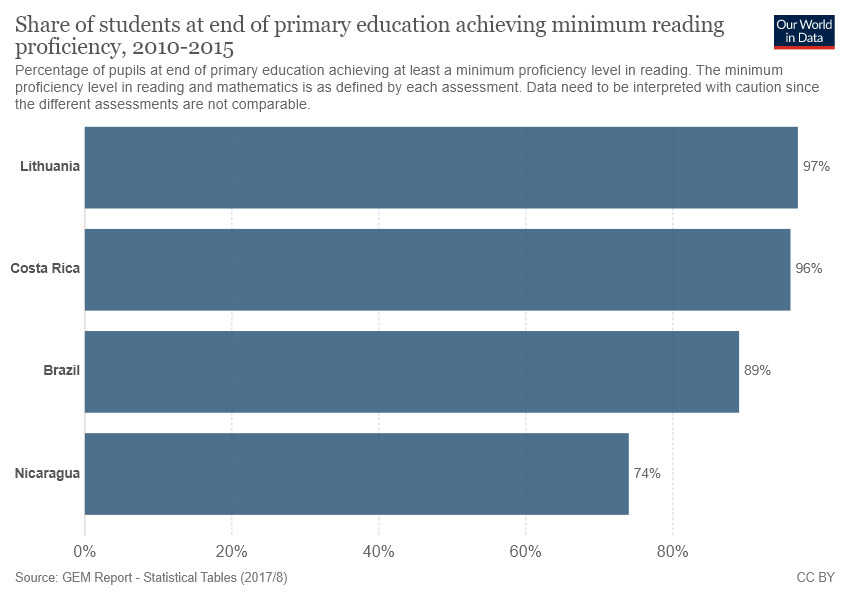Give some essential details in this illustration. At the end of primary education in Brazil, approximately 89% of students achieve minimum reading proficiency. The median of the four bars is greater than 90%. 